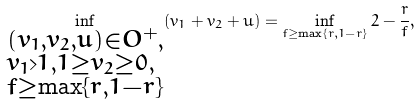<formula> <loc_0><loc_0><loc_500><loc_500>\inf _ { \begin{subarray} { c } ( v _ { 1 } , v _ { 2 } , u ) \in O ^ { + } , \\ v _ { 1 } > 1 , 1 \geq v _ { 2 } \geq 0 , \\ f \geq \max \{ r , 1 - r \} \end{subarray} } ( v _ { 1 } + v _ { 2 } + u ) & = \inf _ { f \geq \max \{ r , 1 - r \} } 2 - \frac { r } { f } ,</formula> 